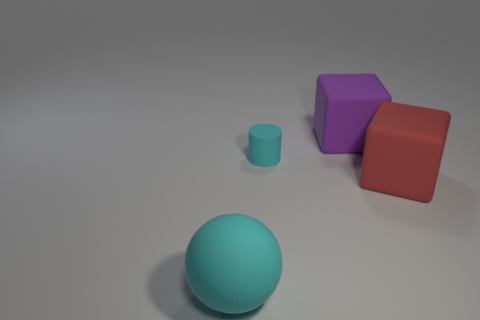Subtract all red cubes. How many cubes are left? 1 Add 1 big cyan rubber spheres. How many objects exist? 5 Subtract 1 purple blocks. How many objects are left? 3 Subtract all spheres. How many objects are left? 3 Subtract 1 cylinders. How many cylinders are left? 0 Subtract all green balls. Subtract all brown blocks. How many balls are left? 1 Subtract all yellow spheres. How many gray cubes are left? 0 Subtract all tiny purple shiny balls. Subtract all large matte cubes. How many objects are left? 2 Add 4 big red matte objects. How many big red matte objects are left? 5 Add 3 tiny rubber objects. How many tiny rubber objects exist? 4 